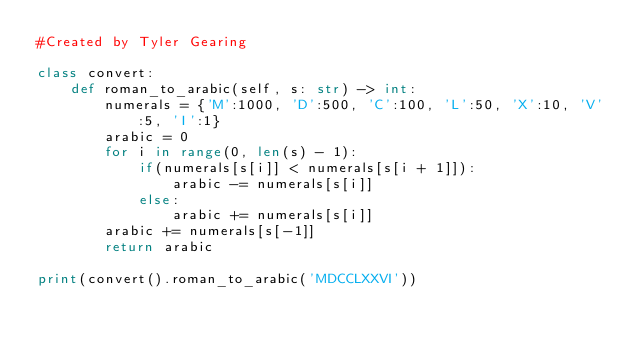<code> <loc_0><loc_0><loc_500><loc_500><_Python_>#Created by Tyler Gearing

class convert:
    def roman_to_arabic(self, s: str) -> int:
        numerals = {'M':1000, 'D':500, 'C':100, 'L':50, 'X':10, 'V':5, 'I':1}
        arabic = 0
        for i in range(0, len(s) - 1):
            if(numerals[s[i]] < numerals[s[i + 1]]):
                arabic -= numerals[s[i]]
            else:
                arabic += numerals[s[i]]
        arabic += numerals[s[-1]]
        return arabic

print(convert().roman_to_arabic('MDCCLXXVI'))
</code> 